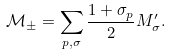<formula> <loc_0><loc_0><loc_500><loc_500>\mathcal { M } _ { \pm } = \sum _ { p , \sigma } \frac { 1 + \sigma _ { p } } { 2 } M _ { \sigma } ^ { \prime } .</formula> 